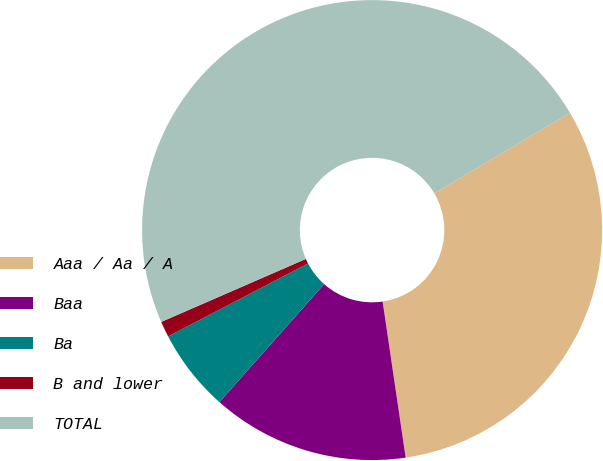Convert chart. <chart><loc_0><loc_0><loc_500><loc_500><pie_chart><fcel>Aaa / Aa / A<fcel>Baa<fcel>Ba<fcel>B and lower<fcel>TOTAL<nl><fcel>31.18%<fcel>13.88%<fcel>5.8%<fcel>1.11%<fcel>48.02%<nl></chart> 